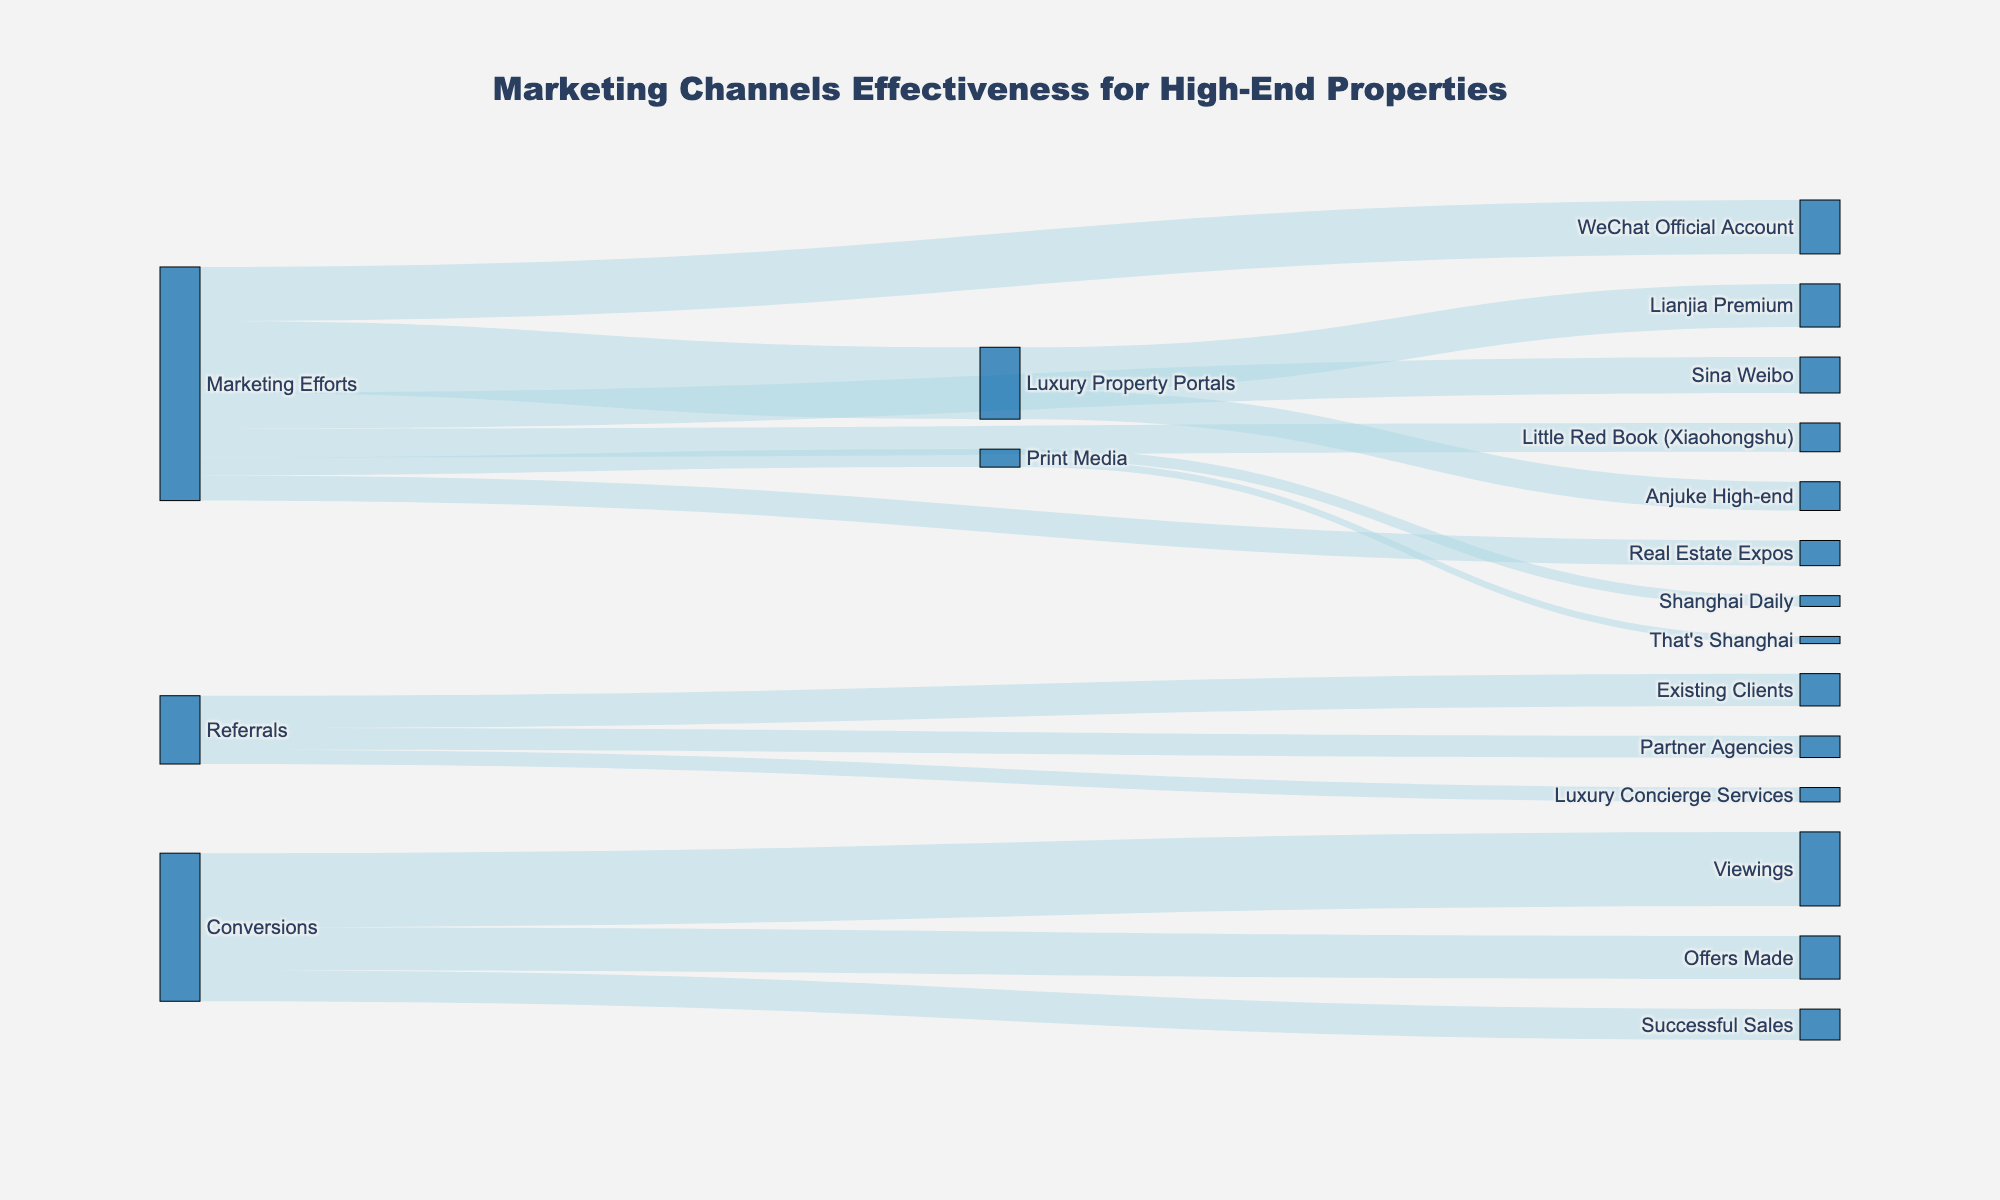How many total leads were generated by the WeChat Official Account? Look at the bar representing the WeChat Official Account connected to Marketing Efforts and find the corresponding lead value.
Answer: 150 Which marketing channel generated the most leads? Compare the lead values connected to each marketing channel originating from Marketing Efforts to determine which has the highest number.
Answer: Luxury Property Portals How many leads are generated from Print Media? Sum the leads generated by "Shanghai Daily" and "That's Shanghai" originating from Print Media.
Answer: 50 (30 + 20) Which referral source has the highest conversion rate? Look at leads and conversions connected to each referral source. Calculate conversion rate (conversions/leads * 100) for each and compare.
Answer: Existing Clients What is the total number of leads generated from referrals? Sum all the leads connected to sources originating from Referrals. This includes Existing Clients, Partner Agencies, and Luxury Concierge Services.
Answer: 190 (90 + 60 + 40) How many successful sales resulted from conversions? Locate the number associated with "Successful Sales" originating from "Conversions".
Answer: 86 Which source has the lowest number of lead-to-conversion ratio? Calculate the lead-to-conversion ratio (conversions/leads) for each source and find the lowest value.
Answer: Print Media (8/50 = 0.16) Between WeChat Official Account and Sina Weibo, which had a higher number of conversions? Compare the conversion values connected to WeChat Official Account and Sina Weibo originating from Marketing Efforts.
Answer: WeChat Official Account (30 vs. 20) What percentage of the total leads did referrals contribute? Calculate the percentage using the total number of leads from referrals and the total number of leads overall. (190/910 * 100)
Answer: 20.88% Which marketing channel generated the least number of leads? Identify the channel with the smallest lead value connected to Marketing Efforts.
Answer: Print Media 